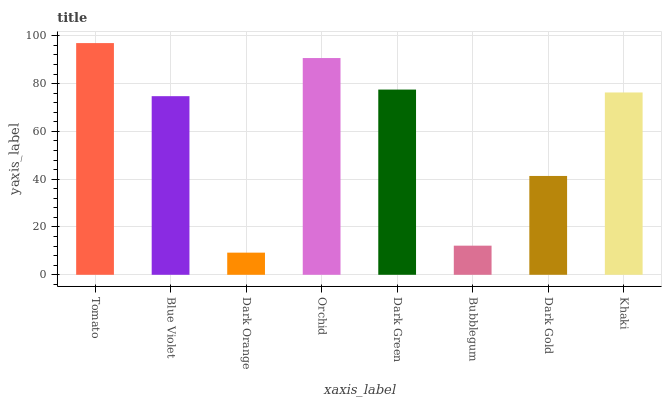Is Dark Orange the minimum?
Answer yes or no. Yes. Is Tomato the maximum?
Answer yes or no. Yes. Is Blue Violet the minimum?
Answer yes or no. No. Is Blue Violet the maximum?
Answer yes or no. No. Is Tomato greater than Blue Violet?
Answer yes or no. Yes. Is Blue Violet less than Tomato?
Answer yes or no. Yes. Is Blue Violet greater than Tomato?
Answer yes or no. No. Is Tomato less than Blue Violet?
Answer yes or no. No. Is Khaki the high median?
Answer yes or no. Yes. Is Blue Violet the low median?
Answer yes or no. Yes. Is Dark Orange the high median?
Answer yes or no. No. Is Orchid the low median?
Answer yes or no. No. 